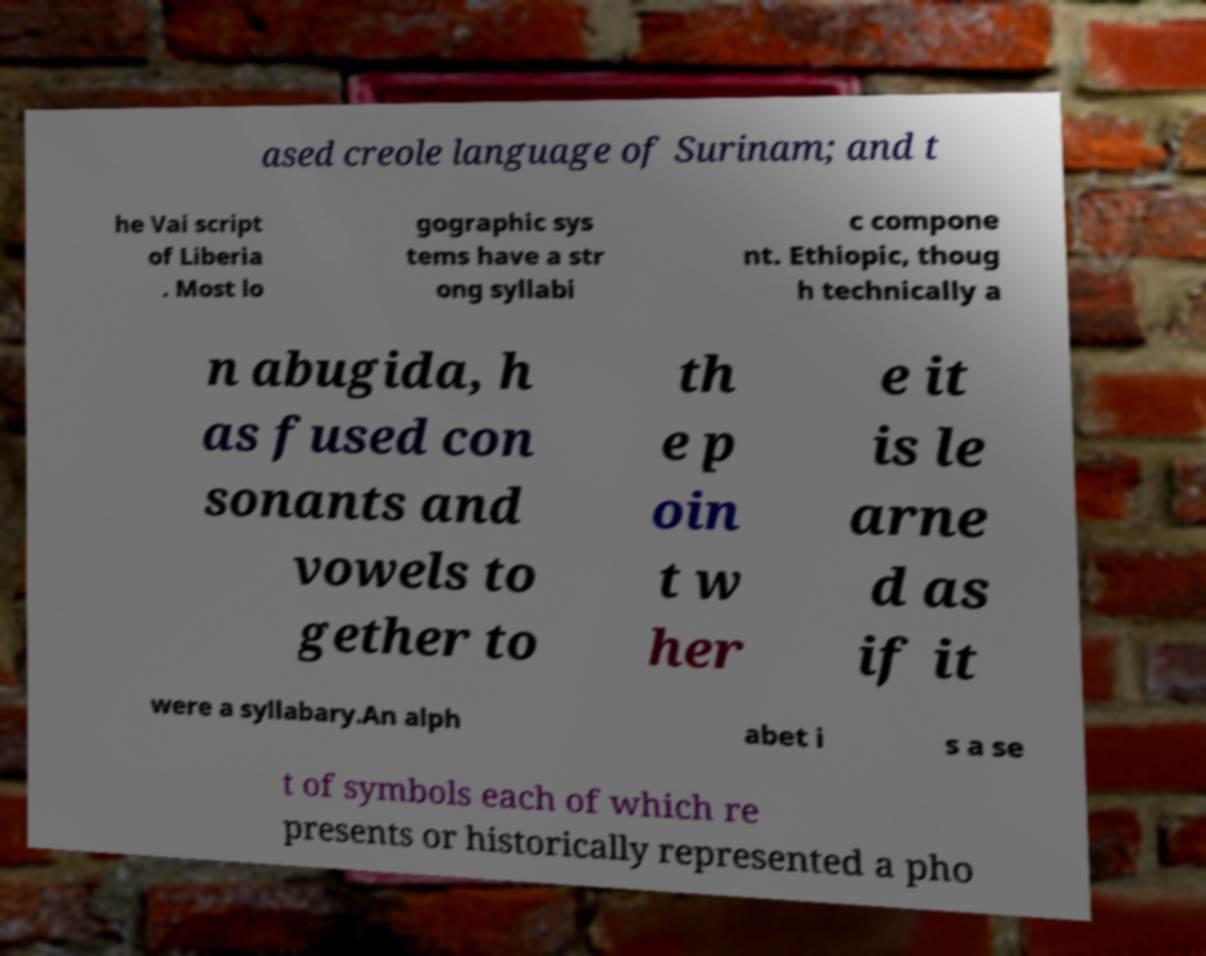I need the written content from this picture converted into text. Can you do that? ased creole language of Surinam; and t he Vai script of Liberia . Most lo gographic sys tems have a str ong syllabi c compone nt. Ethiopic, thoug h technically a n abugida, h as fused con sonants and vowels to gether to th e p oin t w her e it is le arne d as if it were a syllabary.An alph abet i s a se t of symbols each of which re presents or historically represented a pho 